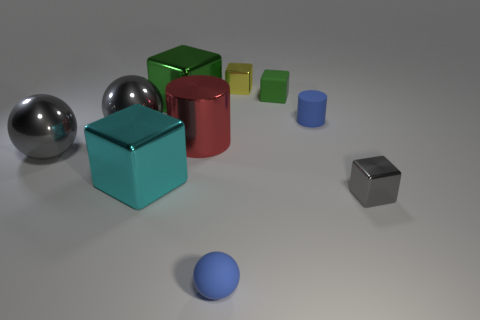How many spheres are either gray metallic things or large metallic objects?
Provide a short and direct response. 2. What is the color of the tiny metallic cube that is in front of the large red object behind the cyan cube?
Offer a very short reply. Gray. What size is the cylinder that is the same color as the small ball?
Give a very brief answer. Small. What number of small blue matte cylinders are to the right of the cylinder on the left side of the small blue thing that is in front of the cyan metal object?
Ensure brevity in your answer.  1. There is a green object to the right of the tiny blue matte ball; does it have the same shape as the blue rubber thing that is behind the cyan shiny block?
Give a very brief answer. No. How many things are either small cyan cylinders or matte things?
Give a very brief answer. 3. What material is the tiny thing that is behind the green cube on the right side of the yellow metal object?
Ensure brevity in your answer.  Metal. Are there any large metallic things of the same color as the small cylinder?
Your answer should be compact. No. There is a cylinder that is the same size as the green matte thing; what is its color?
Ensure brevity in your answer.  Blue. What material is the block on the right side of the small blue matte object behind the gray metal thing right of the big cyan block?
Your answer should be very brief. Metal. 